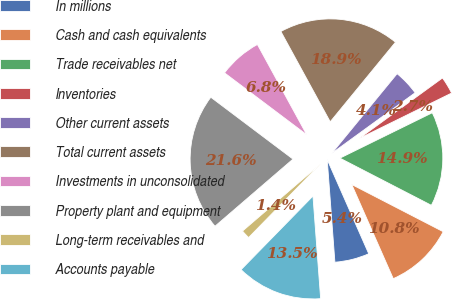Convert chart. <chart><loc_0><loc_0><loc_500><loc_500><pie_chart><fcel>In millions<fcel>Cash and cash equivalents<fcel>Trade receivables net<fcel>Inventories<fcel>Other current assets<fcel>Total current assets<fcel>Investments in unconsolidated<fcel>Property plant and equipment<fcel>Long-term receivables and<fcel>Accounts payable<nl><fcel>5.42%<fcel>10.81%<fcel>14.85%<fcel>2.73%<fcel>4.07%<fcel>18.89%<fcel>6.77%<fcel>21.58%<fcel>1.38%<fcel>13.5%<nl></chart> 